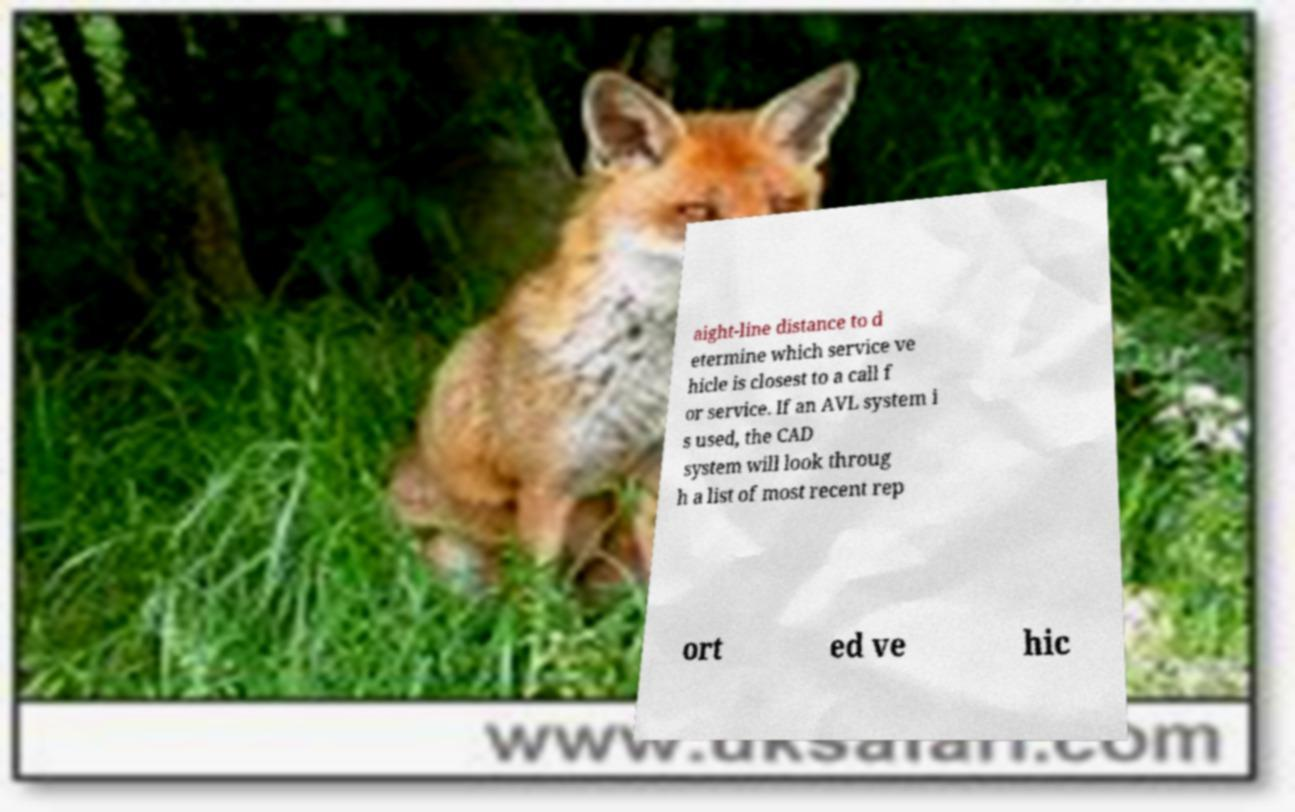For documentation purposes, I need the text within this image transcribed. Could you provide that? aight-line distance to d etermine which service ve hicle is closest to a call f or service. If an AVL system i s used, the CAD system will look throug h a list of most recent rep ort ed ve hic 